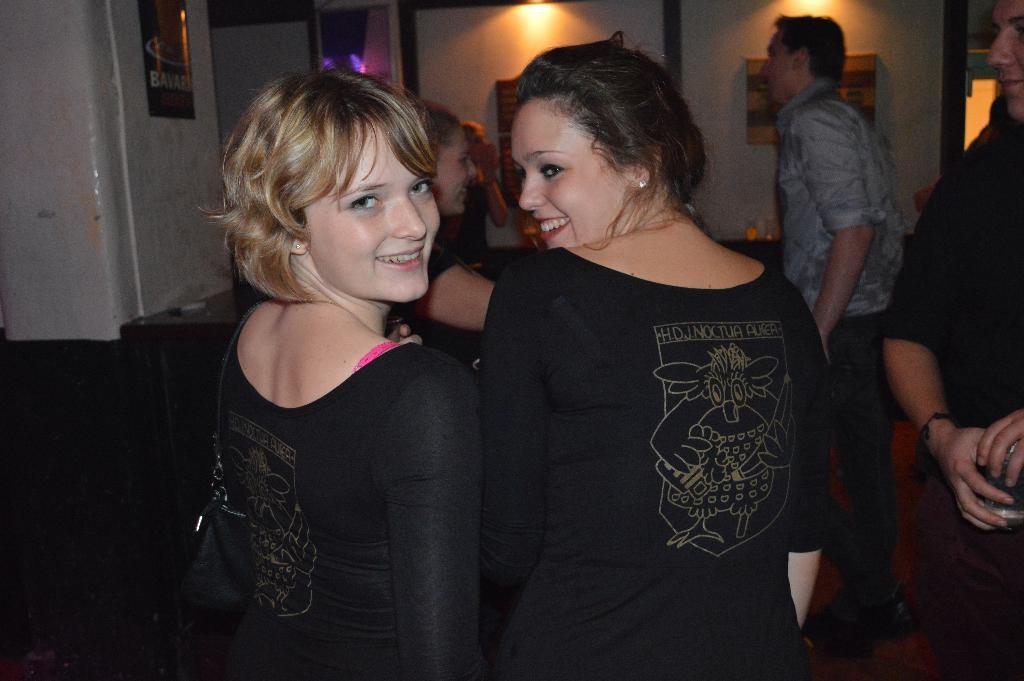In one or two sentences, can you explain what this image depicts? In front of the image there are two women with a smile on their face, in front of them there are a few people, in the background of the image there are a few objects on the table and there are chairs, photo frames, posters and lamps on the walls. 